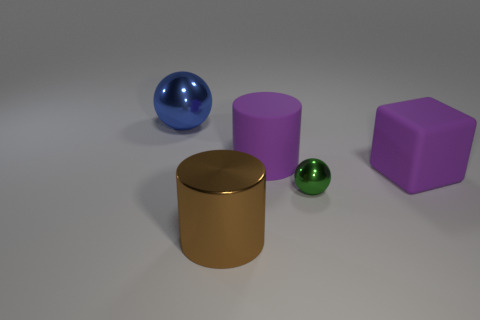The green thing that is the same material as the big brown cylinder is what size?
Offer a terse response. Small. Does the large rubber cube have the same color as the rubber thing that is behind the big block?
Keep it short and to the point. Yes. What number of cylinders are the same color as the matte cube?
Give a very brief answer. 1. Is there a ball made of the same material as the brown cylinder?
Provide a short and direct response. Yes. There is a object that is in front of the green metal object; is it the same size as the green sphere?
Your answer should be very brief. No. There is a rubber block on the right side of the metallic ball that is on the left side of the small green sphere; is there a thing that is in front of it?
Your answer should be very brief. Yes. How many rubber things are tiny cylinders or brown cylinders?
Your answer should be compact. 0. How many other things are the same shape as the big blue object?
Provide a succinct answer. 1. Is the number of big blue balls greater than the number of cylinders?
Give a very brief answer. No. There is a shiny sphere that is behind the cylinder behind the metallic sphere that is to the right of the big blue metallic object; what is its size?
Provide a succinct answer. Large. 